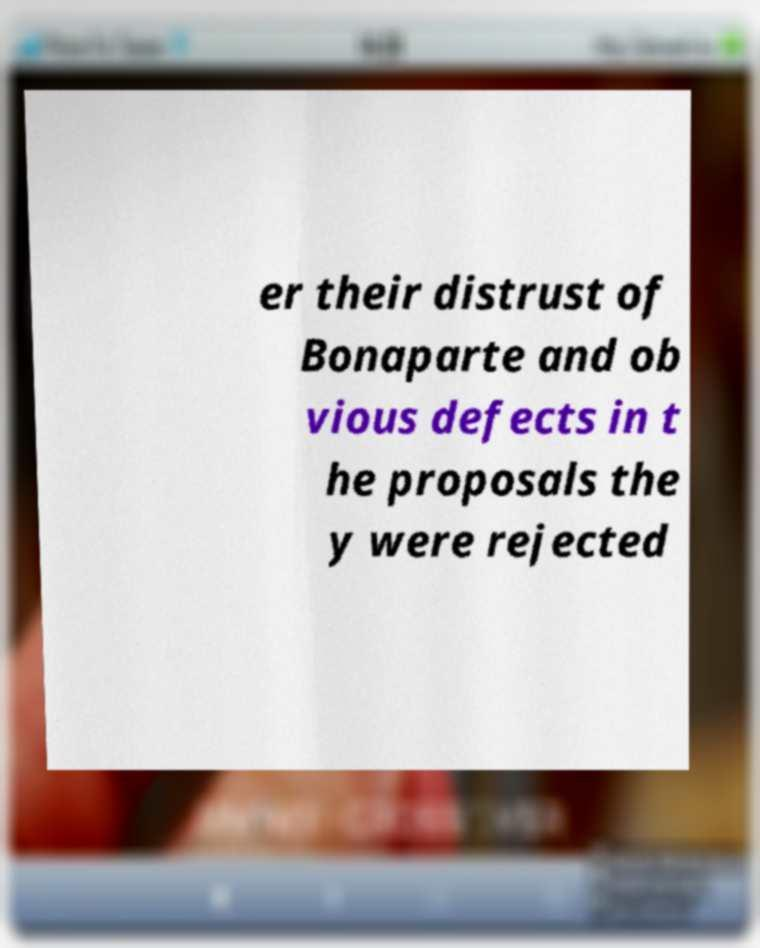For documentation purposes, I need the text within this image transcribed. Could you provide that? er their distrust of Bonaparte and ob vious defects in t he proposals the y were rejected 